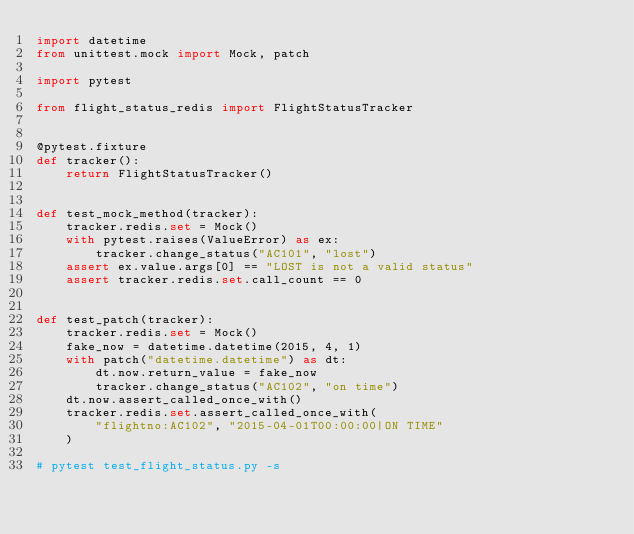<code> <loc_0><loc_0><loc_500><loc_500><_Python_>import datetime
from unittest.mock import Mock, patch

import pytest

from flight_status_redis import FlightStatusTracker


@pytest.fixture
def tracker():
    return FlightStatusTracker()


def test_mock_method(tracker):
    tracker.redis.set = Mock()
    with pytest.raises(ValueError) as ex:
        tracker.change_status("AC101", "lost")
    assert ex.value.args[0] == "LOST is not a valid status"
    assert tracker.redis.set.call_count == 0


def test_patch(tracker):
    tracker.redis.set = Mock()
    fake_now = datetime.datetime(2015, 4, 1)
    with patch("datetime.datetime") as dt:
        dt.now.return_value = fake_now
        tracker.change_status("AC102", "on time")
    dt.now.assert_called_once_with()
    tracker.redis.set.assert_called_once_with(
        "flightno:AC102", "2015-04-01T00:00:00|ON TIME"
    )

# pytest test_flight_status.py -s
</code> 